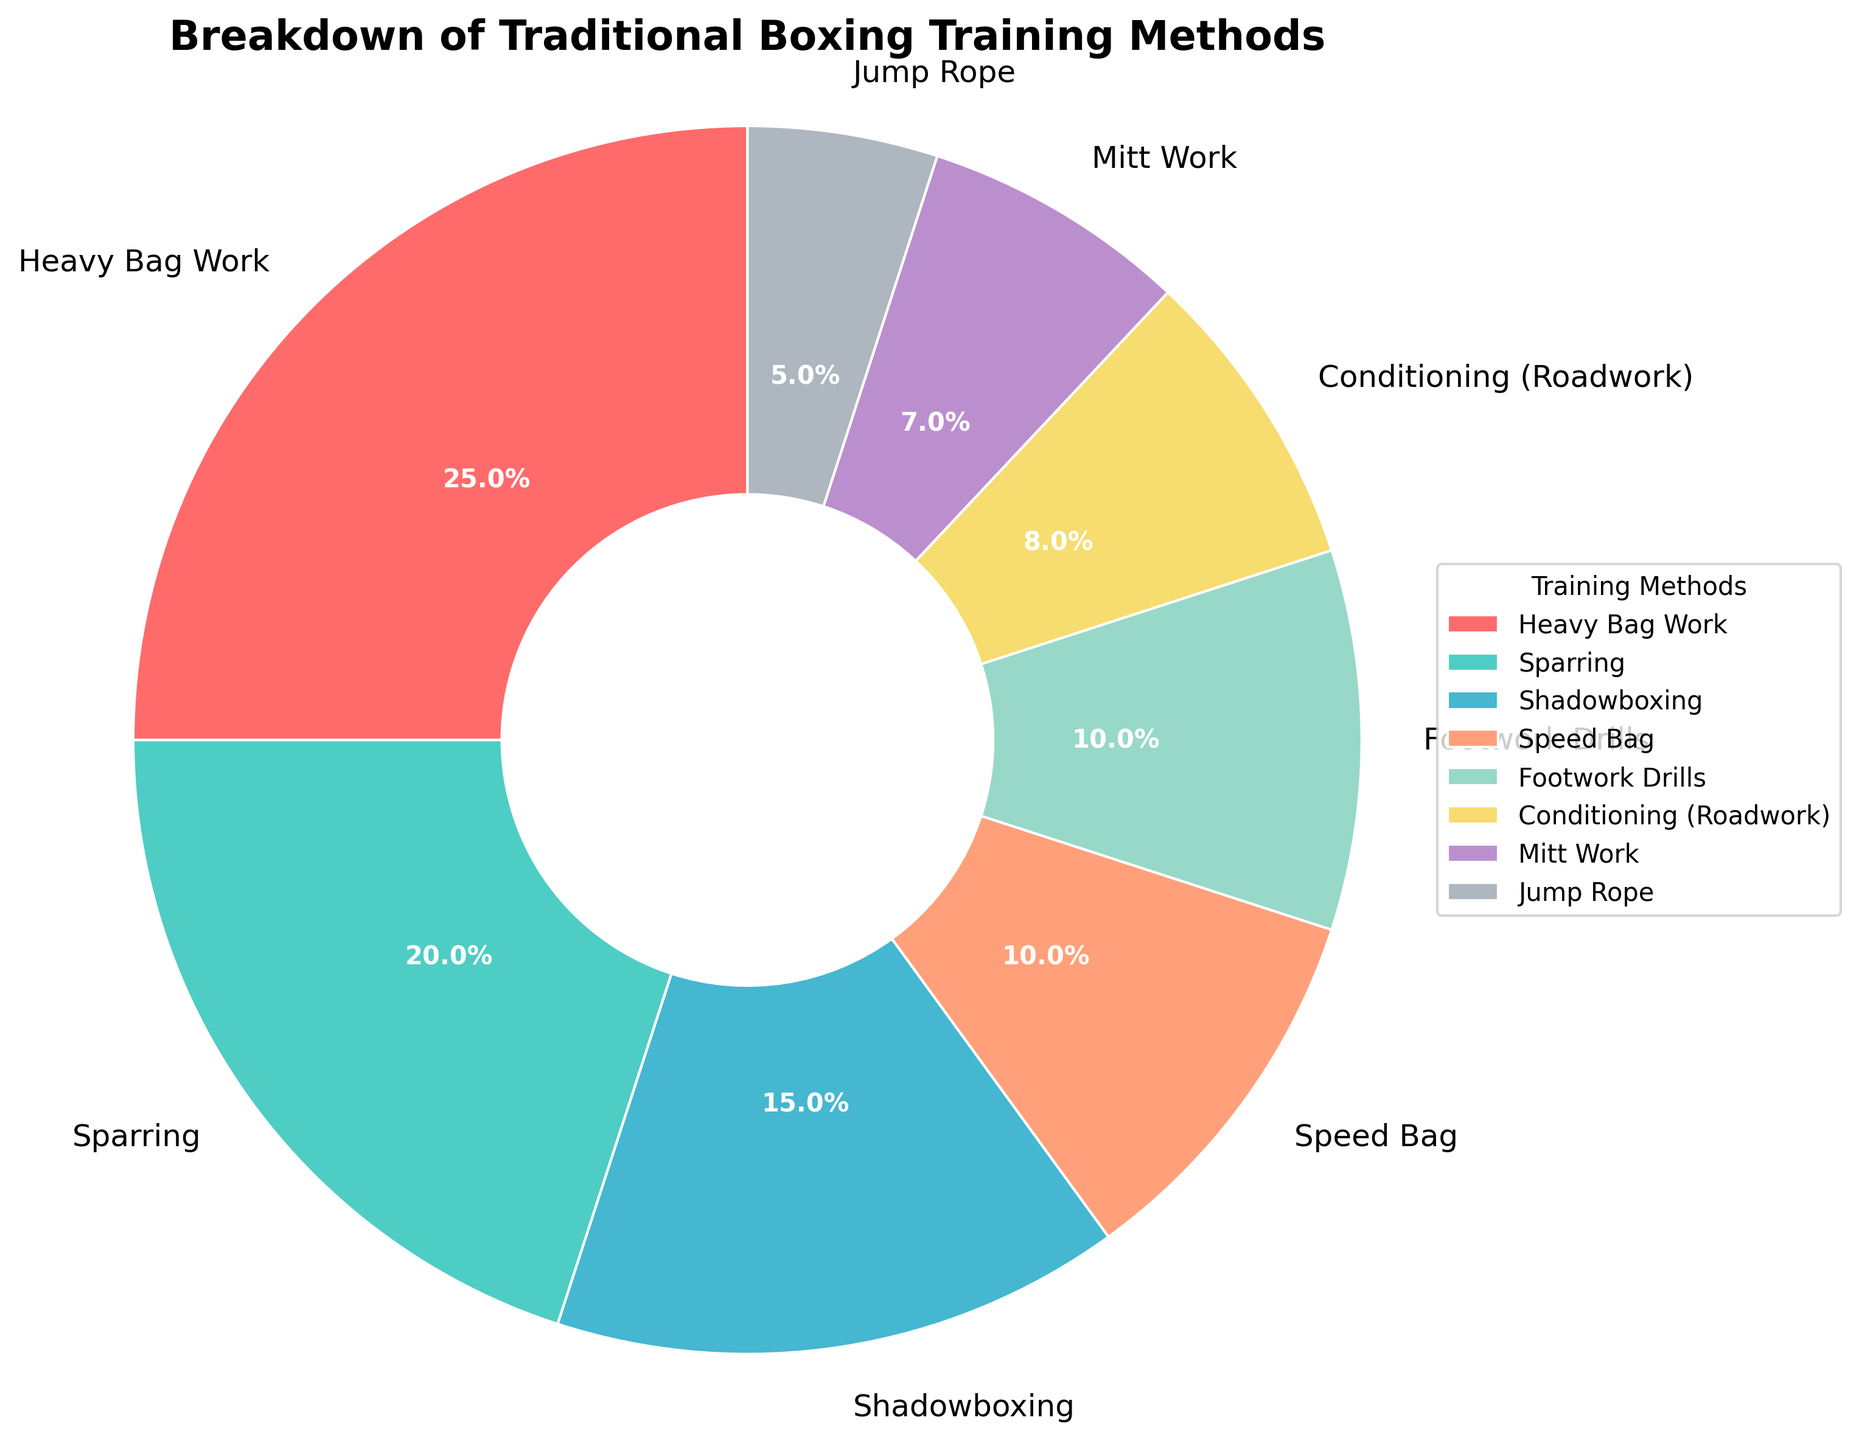How much more time is spent on Heavy Bag Work compared to Speed Bag work? To determine the difference in time spent, subtract the percentage of time spent on Speed Bag work from the percentage of time spent on Heavy Bag Work. Heavy Bag Work is 25% and Speed Bag is 10%, so the difference is 25% - 10% = 15%.
Answer: 15% What's the sum of the percentages of time spent on Sparring and Shadowboxing? Add the percentages of time spent on Sparring and Shadowboxing. Sparring is 20% and Shadowboxing is 15%, so the total is 20% + 15% = 35%.
Answer: 35% Which training method takes up the least time? Look for the smallest percentage value in the pie chart. Jump Rope has the smallest percentage at 5%.
Answer: Jump Rope Which training methods use the same amount of time? Identify the training methods with equal percentages. Speed Bag work and Footwork Drills both take up 10%.
Answer: Speed Bag, Footwork Drills How many training methods take up more than 15% of the time? Count the number of training methods with percentages greater than 15%. Two methods, Heavy Bag Work (25%) and Sparring (20%), meet this criterion.
Answer: Two What is the average time spent on Mitt Work and Jump Rope? To find the average, add the percentages of Mitt Work and Jump Rope, then divide by 2. Mitt Work is 7% and Jump Rope is 5%, so the average is (7% + 5%) / 2 = 6%.
Answer: 6% What percentage of the total time is spent on Footwork Drills and Conditioning (Roadwork) combined? Add the percentages of Footwork Drills and Conditioning (Roadwork). Footwork Drills are 10% and Conditioning (Roadwork) is 8%, so the total is 10% + 8% = 18%.
Answer: 18% Which training method follows Mitt Work in terms of the percentage of time spent? Look for the training method with the next higher percentage after Mitt Work. Mitt Work is 7%, followed by Conditioning (Roadwork) at 8%.
Answer: Conditioning (Roadwork) If the time spent on Sparring and Shadowboxing were doubled, what would be their new combined percentage of the total training time? First, double the percentages of both Sparring and Shadowboxing, then sum the results. Sparring is 20% and if doubled becomes 40%, Shadowboxing is 15% and if doubled becomes 30%. The new combined percentage is 40% + 30% = 70%.
Answer: 70% 